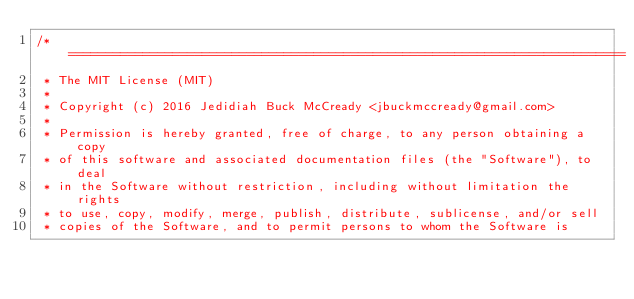Convert code to text. <code><loc_0><loc_0><loc_500><loc_500><_C++_>/* ===========================================================================
 * The MIT License (MIT)
 *
 * Copyright (c) 2016 Jedidiah Buck McCready <jbuckmccready@gmail.com>
 *
 * Permission is hereby granted, free of charge, to any person obtaining a copy
 * of this software and associated documentation files (the "Software"), to deal
 * in the Software without restriction, including without limitation the rights
 * to use, copy, modify, merge, publish, distribute, sublicense, and/or sell
 * copies of the Software, and to permit persons to whom the Software is</code> 